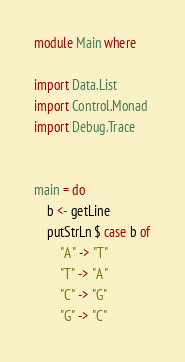<code> <loc_0><loc_0><loc_500><loc_500><_Haskell_>module Main where

import Data.List
import Control.Monad
import Debug.Trace


main = do
    b <- getLine
    putStrLn $ case b of
        "A" -> "T"
        "T" -> "A"
        "C" -> "G"
        "G" -> "C"

</code> 